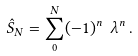<formula> <loc_0><loc_0><loc_500><loc_500>\hat { S } _ { N } = \sum _ { 0 } ^ { N } ( - 1 ) ^ { n } \ \lambda ^ { n } \, .</formula> 